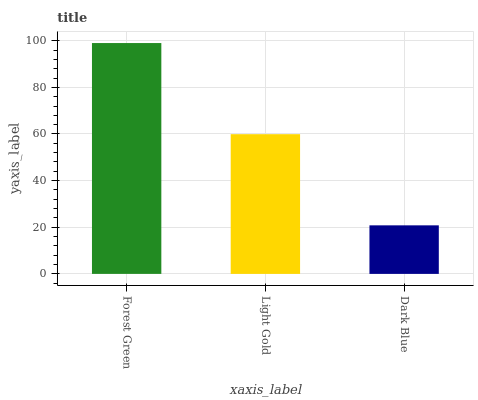Is Dark Blue the minimum?
Answer yes or no. Yes. Is Forest Green the maximum?
Answer yes or no. Yes. Is Light Gold the minimum?
Answer yes or no. No. Is Light Gold the maximum?
Answer yes or no. No. Is Forest Green greater than Light Gold?
Answer yes or no. Yes. Is Light Gold less than Forest Green?
Answer yes or no. Yes. Is Light Gold greater than Forest Green?
Answer yes or no. No. Is Forest Green less than Light Gold?
Answer yes or no. No. Is Light Gold the high median?
Answer yes or no. Yes. Is Light Gold the low median?
Answer yes or no. Yes. Is Dark Blue the high median?
Answer yes or no. No. Is Dark Blue the low median?
Answer yes or no. No. 